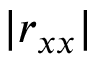<formula> <loc_0><loc_0><loc_500><loc_500>| r _ { x x } |</formula> 